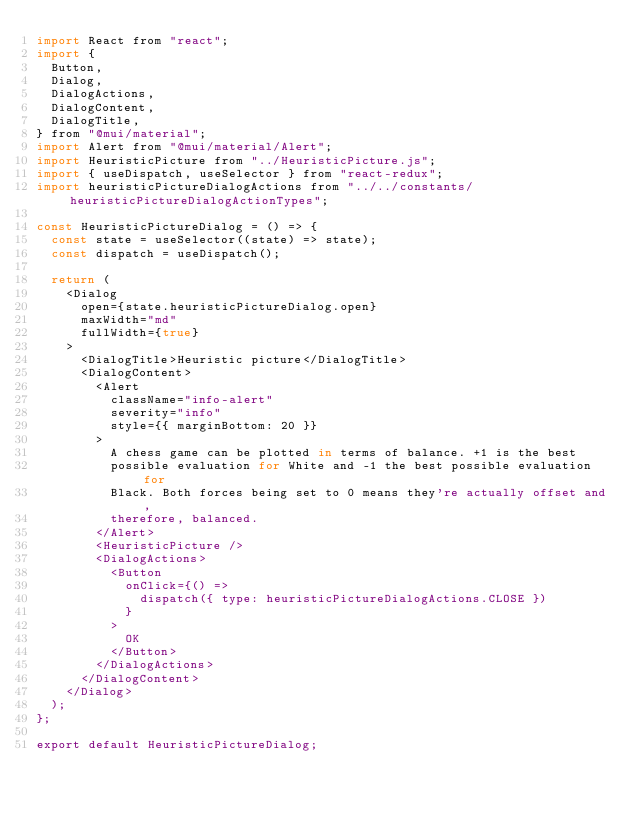<code> <loc_0><loc_0><loc_500><loc_500><_JavaScript_>import React from "react";
import {
  Button,
  Dialog,
  DialogActions,
  DialogContent,
  DialogTitle,
} from "@mui/material";
import Alert from "@mui/material/Alert";
import HeuristicPicture from "../HeuristicPicture.js";
import { useDispatch, useSelector } from "react-redux";
import heuristicPictureDialogActions from "../../constants/heuristicPictureDialogActionTypes";

const HeuristicPictureDialog = () => {
  const state = useSelector((state) => state);
  const dispatch = useDispatch();

  return (
    <Dialog
      open={state.heuristicPictureDialog.open}
      maxWidth="md"
      fullWidth={true}
    >
      <DialogTitle>Heuristic picture</DialogTitle>
      <DialogContent>
        <Alert
          className="info-alert"
          severity="info"
          style={{ marginBottom: 20 }}
        >
          A chess game can be plotted in terms of balance. +1 is the best
          possible evaluation for White and -1 the best possible evaluation for
          Black. Both forces being set to 0 means they're actually offset and,
          therefore, balanced.
        </Alert>
        <HeuristicPicture />
        <DialogActions>
          <Button
            onClick={() =>
              dispatch({ type: heuristicPictureDialogActions.CLOSE })
            }
          >
            OK
          </Button>
        </DialogActions>
      </DialogContent>
    </Dialog>
  );
};

export default HeuristicPictureDialog;
</code> 